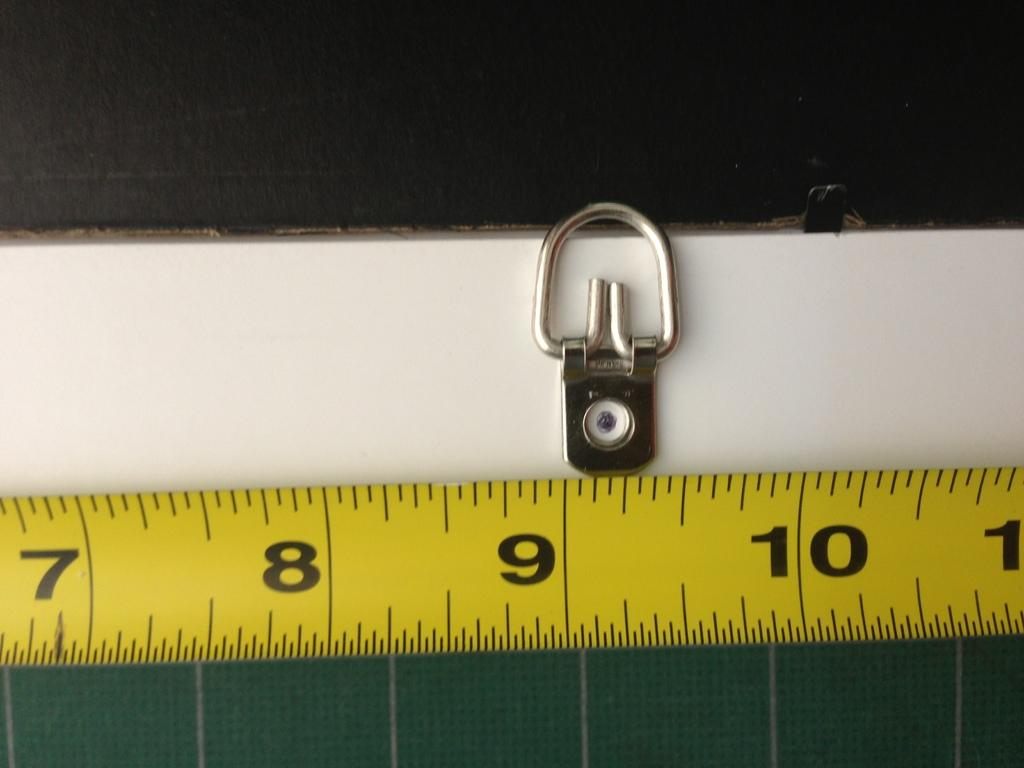<image>
Offer a succinct explanation of the picture presented. A yellow metal retractable tape measure showing 7 8 and 9. 